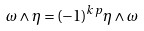Convert formula to latex. <formula><loc_0><loc_0><loc_500><loc_500>\omega \wedge \eta = ( - 1 ) ^ { k p } \eta \wedge \omega</formula> 